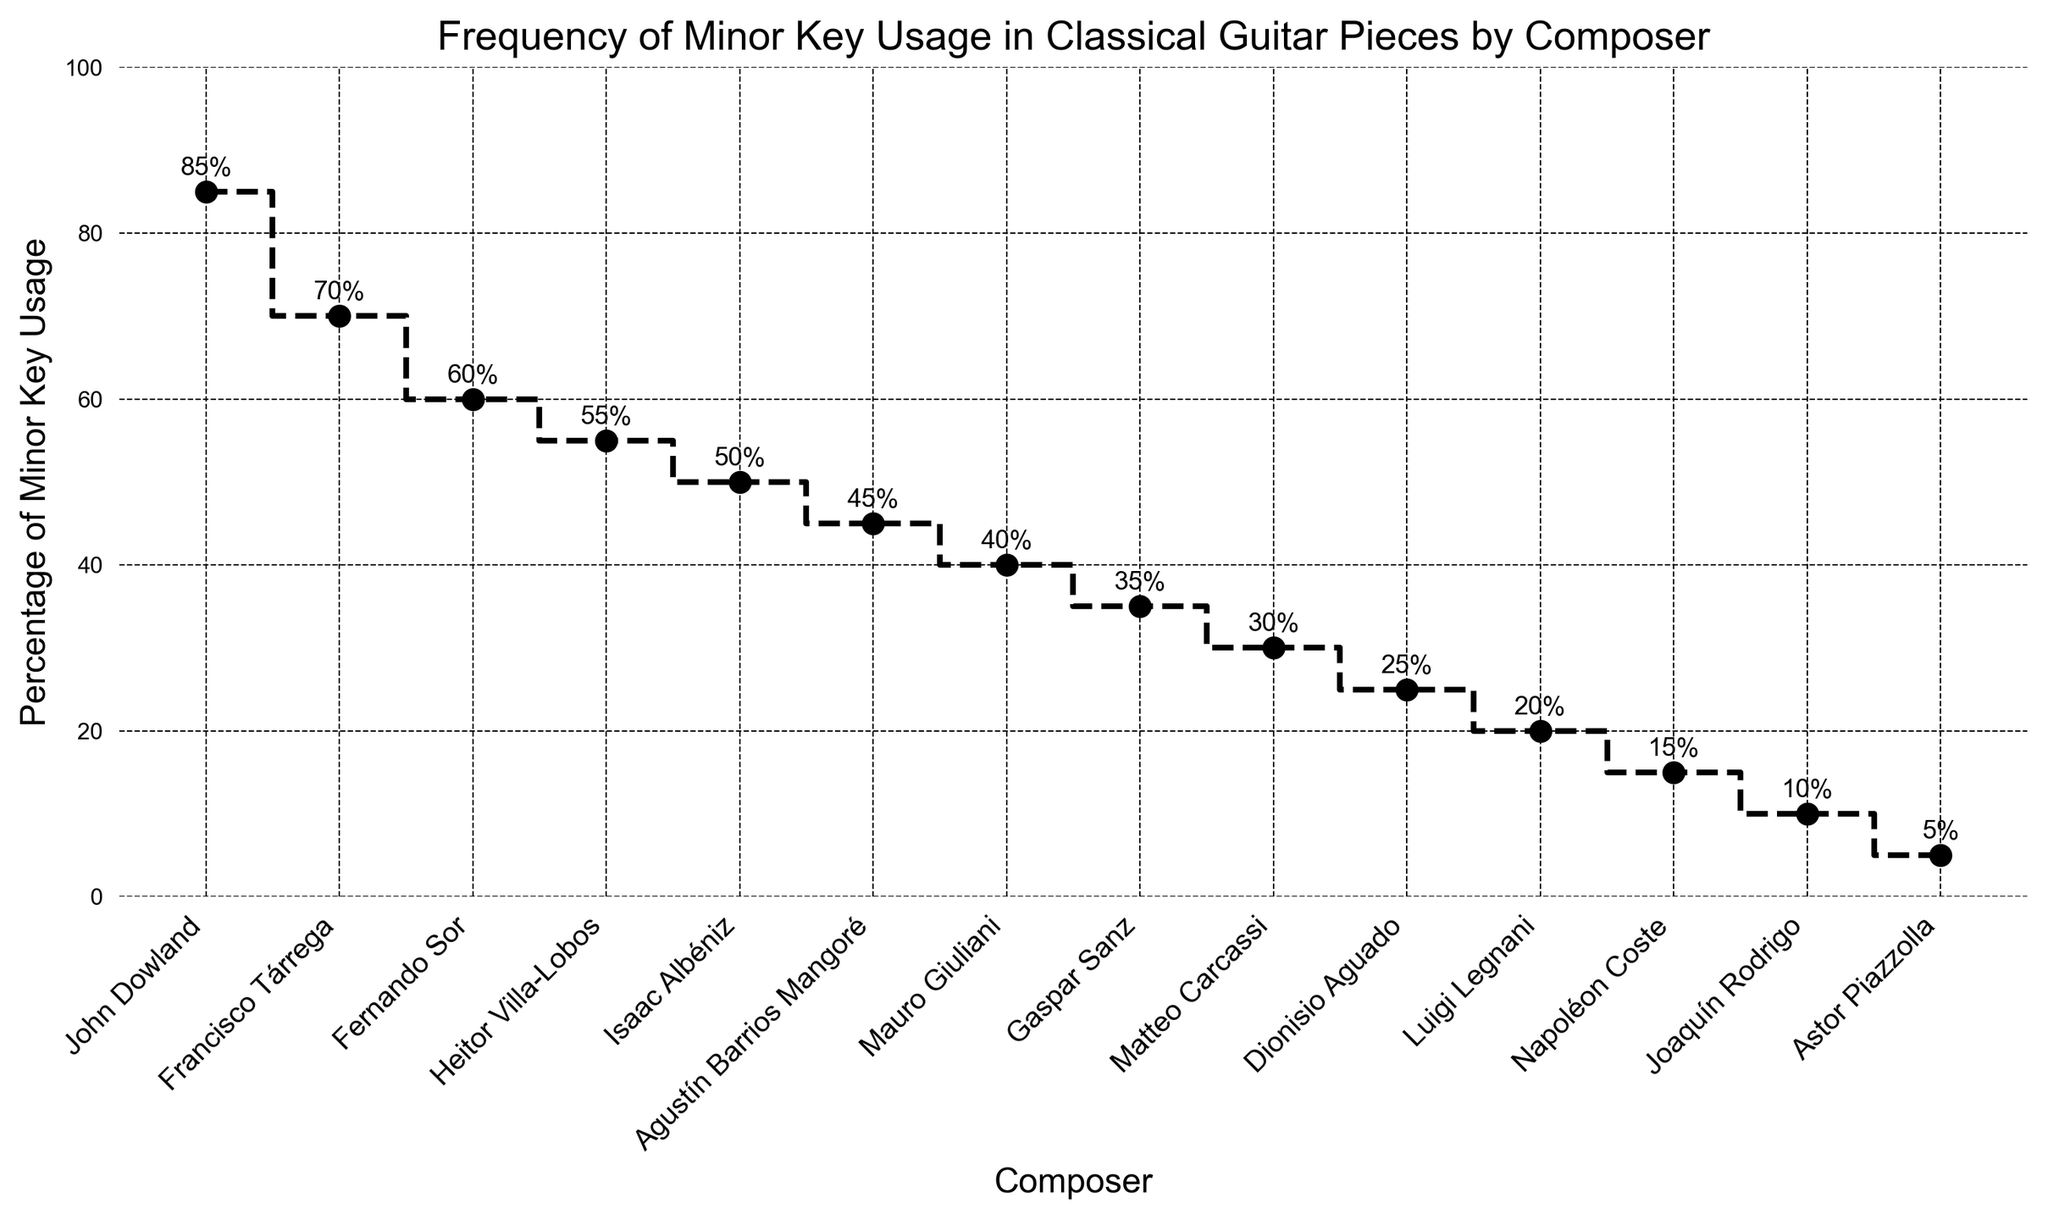which composer has the highest percentage of minor key usage? John Dowland has the highest percentage of minor key usage. This is indicated by the first point on the plot, which shows John Dowland at 85%.
Answer: John Dowland which two composers have the closest percentage of minor key usage? Fernando Sor and Heitor Villa-Lobos have the closest percentage, at 60% and 55%, respectively. The two markers are visually close to each other on the plot.
Answer: Fernando Sor and Heitor Villa-Lobos what is the difference in minor key usage between Francisco Tárrega and Joaquín Rodrigo? The percentage for Francisco Tárrega is 70%, while for Joaquín Rodrigo, it's 10%. Subtract 10% from 70% to get 60%.
Answer: 60% what is the median percentage of minor key usage among the composers displayed? To find the median, first list the percentages in ascending order: 5, 10, 15, 20, 25, 30, 35, 40, 45, 50, 55, 60, 70, 85. There are 14 values, so the median is the average of the 7th and 8th values (35 and 40), which is (35 + 40)/2 = 37.5.
Answer: 37.5 how much higher is John Dowland's minor key usage compared to Francisco Tárrega's? John Dowland's usage is 85%, and Francisco Tárrega's is 70%. The difference is 85% - 70% = 15%.
Answer: 15% which composer has a minor key usage percentage equal to 45%? The composer with a minor key usage percentage of 45% is Agustín Barrios Mangoré, as shown by the marker at 45%.
Answer: Agustín Barrios Mangoré which two composers usage add up to more than 100%? John Dowland and Francisco Tárrega have percentages of 85% and 70%, respectively. Their sum is 85% + 70% = 155%, which is greater than 100%.
Answer: John Dowland and Francisco Tárrega what percentage of minor key usage is represented by the composer in the middle of the list? The list of percentages is ordered from highest to lowest, so the middle percentage, which corresponds to Gaspar Sanz, is 35%.
Answer: 35% how many composers have a minor key usage percentage below 30%? The composers below 30% are Matteo Carcassi, Dionisio Aguado, Luigi Legnani, Napoléon Coste, Joaquín Rodrigo, and Astor Piazzolla. Count them to get 6 composers.
Answer: 6 